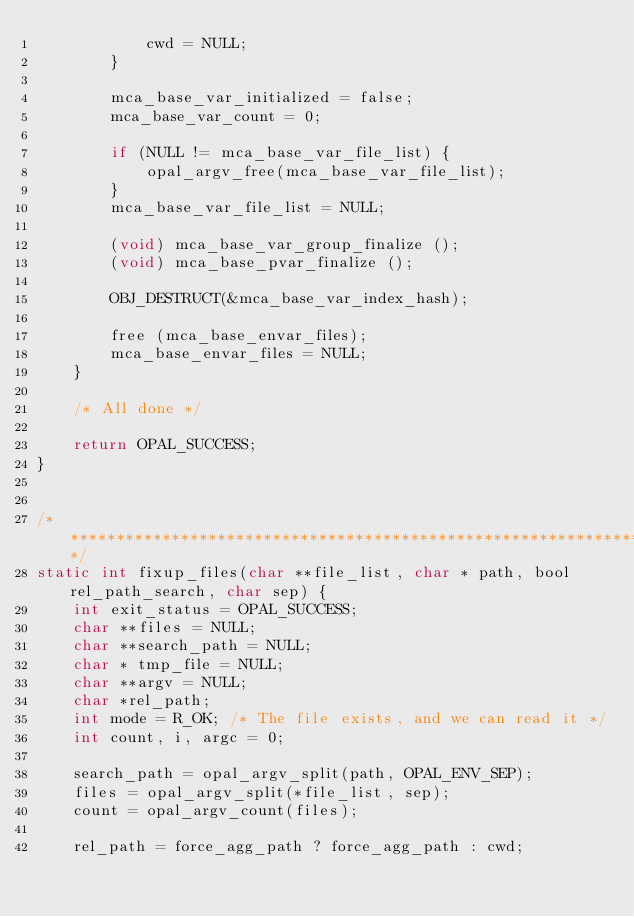<code> <loc_0><loc_0><loc_500><loc_500><_C_>            cwd = NULL;
        }

        mca_base_var_initialized = false;
        mca_base_var_count = 0;

        if (NULL != mca_base_var_file_list) {
            opal_argv_free(mca_base_var_file_list);
        }
        mca_base_var_file_list = NULL;

        (void) mca_base_var_group_finalize ();
        (void) mca_base_pvar_finalize ();

        OBJ_DESTRUCT(&mca_base_var_index_hash);

        free (mca_base_envar_files);
        mca_base_envar_files = NULL;
    }

    /* All done */

    return OPAL_SUCCESS;
}


/*************************************************************************/
static int fixup_files(char **file_list, char * path, bool rel_path_search, char sep) {
    int exit_status = OPAL_SUCCESS;
    char **files = NULL;
    char **search_path = NULL;
    char * tmp_file = NULL;
    char **argv = NULL;
    char *rel_path;
    int mode = R_OK; /* The file exists, and we can read it */
    int count, i, argc = 0;

    search_path = opal_argv_split(path, OPAL_ENV_SEP);
    files = opal_argv_split(*file_list, sep);
    count = opal_argv_count(files);

    rel_path = force_agg_path ? force_agg_path : cwd;
</code> 